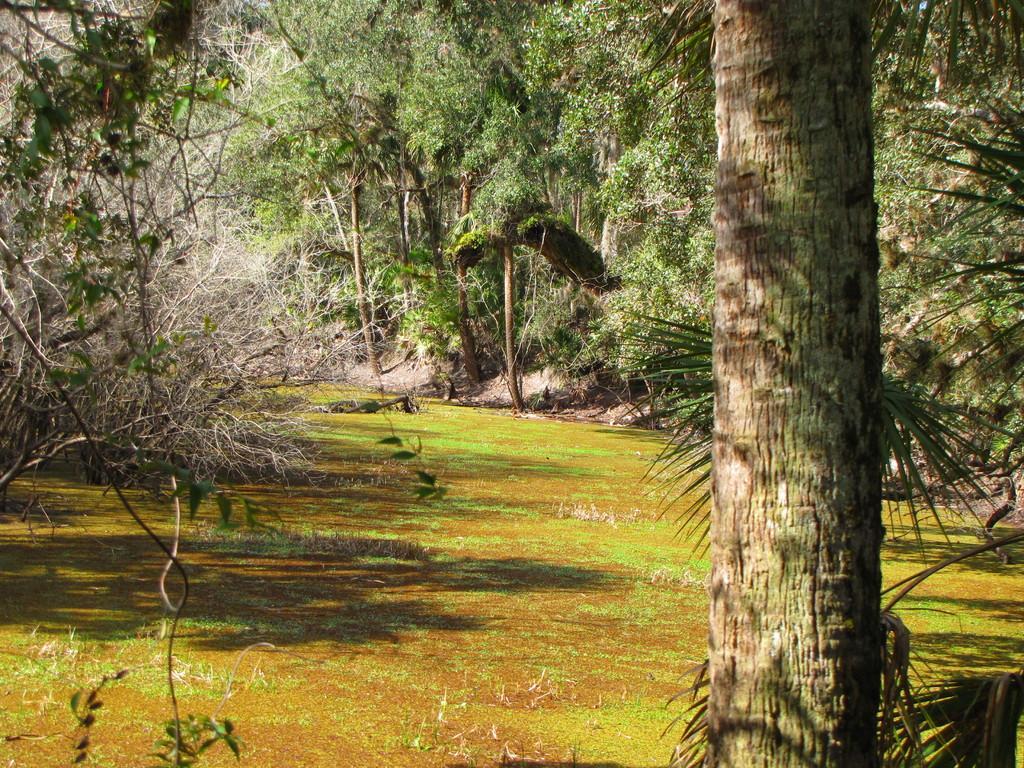Please provide a concise description of this image. In this picture there is a trunk on the right side of the image and there are trees around the area of the image. 